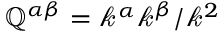<formula> <loc_0><loc_0><loc_500><loc_500>\mathbb { Q } ^ { \alpha \beta } = \mathcal { k } ^ { \alpha } \mathcal { k } ^ { \beta } / \mathcal { k } ^ { 2 }</formula> 